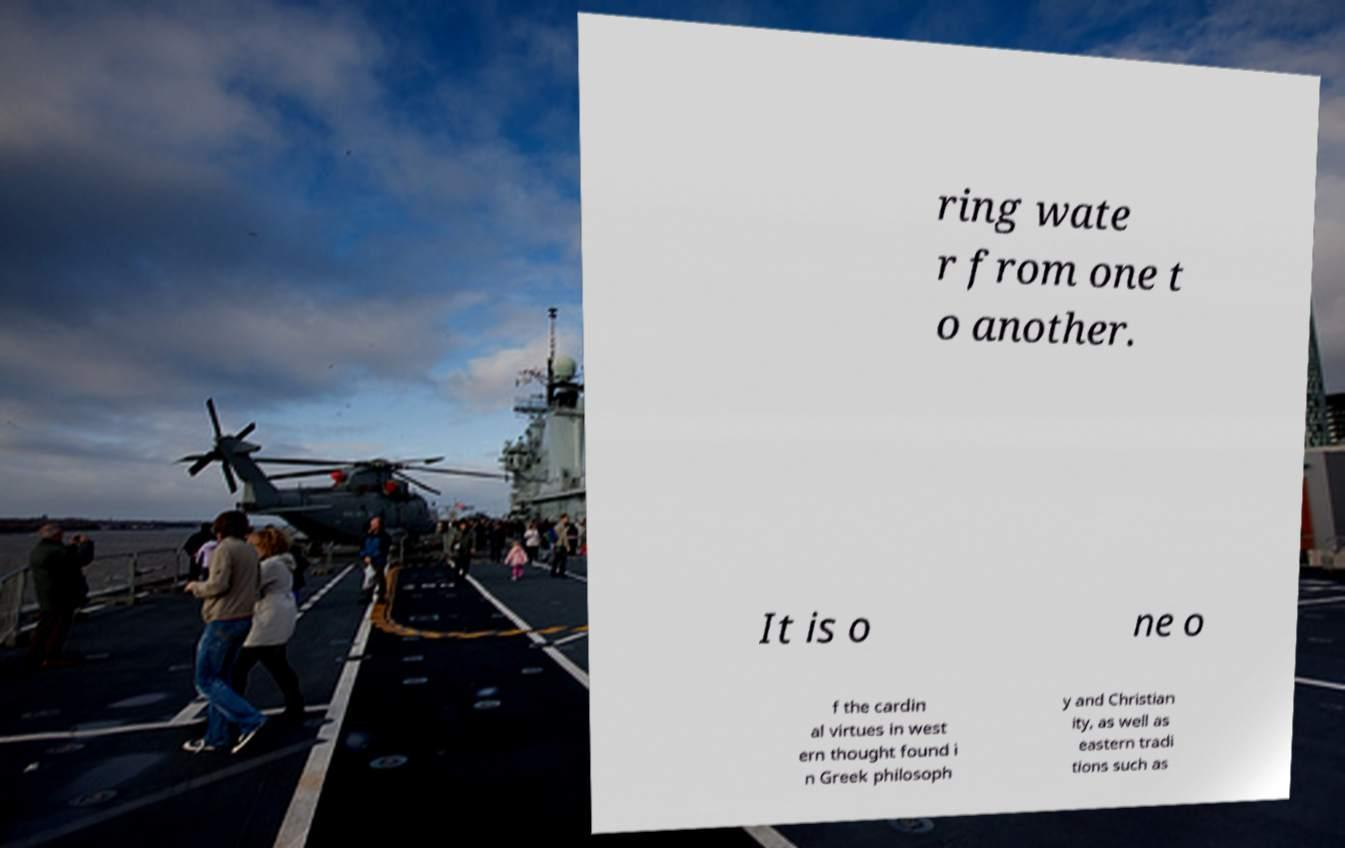I need the written content from this picture converted into text. Can you do that? ring wate r from one t o another. It is o ne o f the cardin al virtues in west ern thought found i n Greek philosoph y and Christian ity, as well as eastern tradi tions such as 